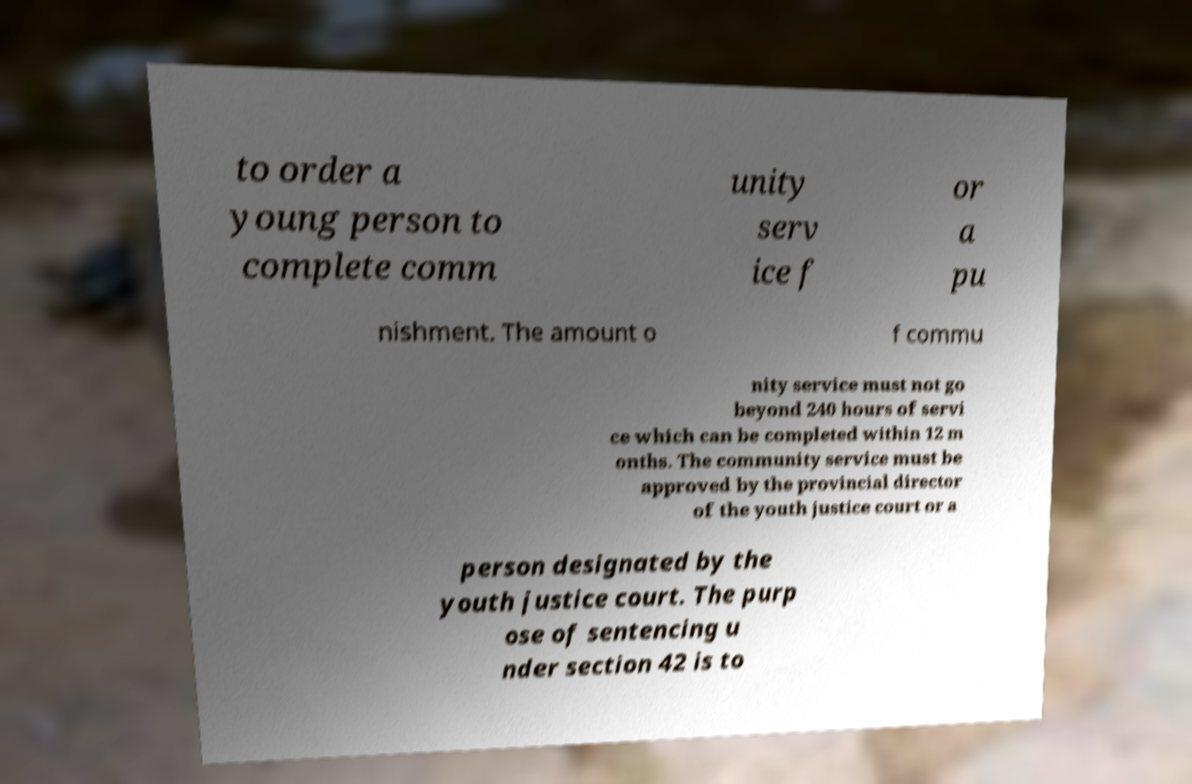There's text embedded in this image that I need extracted. Can you transcribe it verbatim? to order a young person to complete comm unity serv ice f or a pu nishment. The amount o f commu nity service must not go beyond 240 hours of servi ce which can be completed within 12 m onths. The community service must be approved by the provincial director of the youth justice court or a person designated by the youth justice court. The purp ose of sentencing u nder section 42 is to 